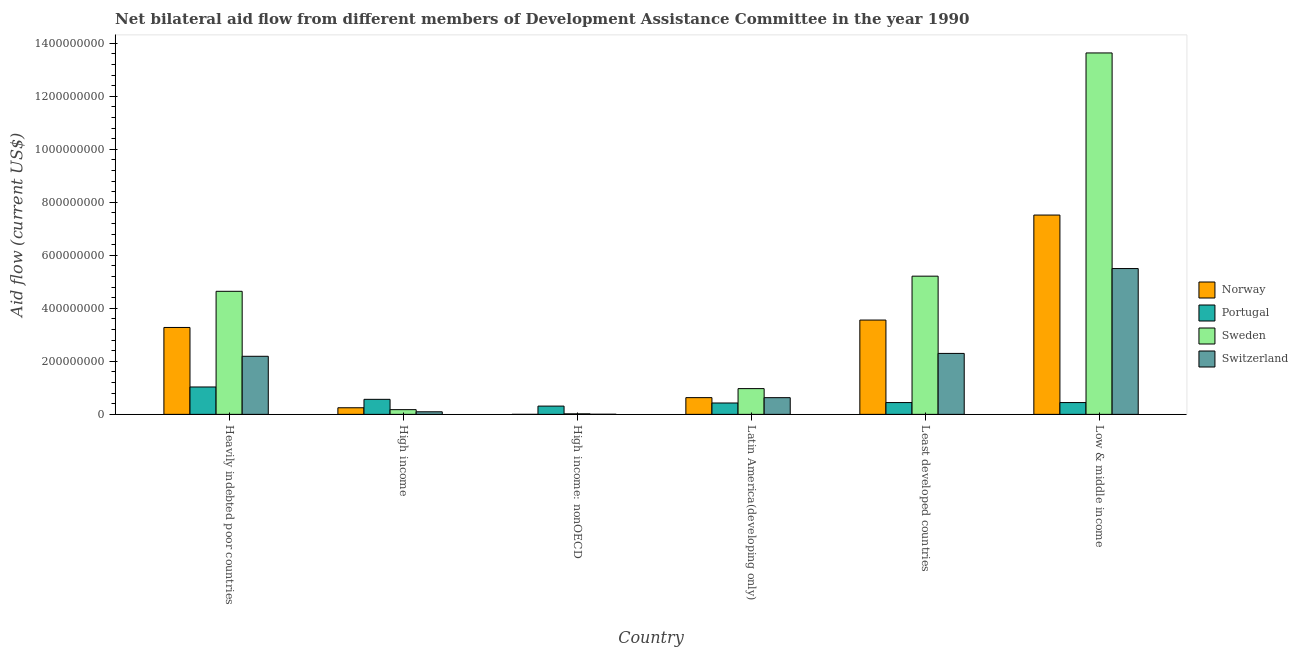How many different coloured bars are there?
Your answer should be very brief. 4. Are the number of bars per tick equal to the number of legend labels?
Your response must be concise. Yes. Are the number of bars on each tick of the X-axis equal?
Give a very brief answer. Yes. How many bars are there on the 1st tick from the left?
Your answer should be very brief. 4. How many bars are there on the 2nd tick from the right?
Provide a succinct answer. 4. What is the label of the 3rd group of bars from the left?
Provide a short and direct response. High income: nonOECD. What is the amount of aid given by norway in Low & middle income?
Offer a terse response. 7.52e+08. Across all countries, what is the maximum amount of aid given by switzerland?
Your answer should be very brief. 5.50e+08. Across all countries, what is the minimum amount of aid given by portugal?
Your response must be concise. 3.12e+07. In which country was the amount of aid given by sweden maximum?
Your response must be concise. Low & middle income. In which country was the amount of aid given by portugal minimum?
Keep it short and to the point. High income: nonOECD. What is the total amount of aid given by norway in the graph?
Make the answer very short. 1.52e+09. What is the difference between the amount of aid given by sweden in Heavily indebted poor countries and that in Low & middle income?
Ensure brevity in your answer.  -8.99e+08. What is the difference between the amount of aid given by switzerland in Latin America(developing only) and the amount of aid given by norway in Low & middle income?
Your answer should be very brief. -6.89e+08. What is the average amount of aid given by norway per country?
Provide a short and direct response. 2.54e+08. What is the difference between the amount of aid given by sweden and amount of aid given by norway in Latin America(developing only)?
Provide a short and direct response. 3.40e+07. What is the ratio of the amount of aid given by sweden in Heavily indebted poor countries to that in Least developed countries?
Your answer should be very brief. 0.89. Is the difference between the amount of aid given by norway in Heavily indebted poor countries and High income greater than the difference between the amount of aid given by switzerland in Heavily indebted poor countries and High income?
Give a very brief answer. Yes. What is the difference between the highest and the second highest amount of aid given by portugal?
Provide a short and direct response. 4.66e+07. What is the difference between the highest and the lowest amount of aid given by sweden?
Offer a terse response. 1.36e+09. In how many countries, is the amount of aid given by portugal greater than the average amount of aid given by portugal taken over all countries?
Offer a very short reply. 2. What does the 4th bar from the left in High income represents?
Offer a terse response. Switzerland. Is it the case that in every country, the sum of the amount of aid given by norway and amount of aid given by portugal is greater than the amount of aid given by sweden?
Your answer should be very brief. No. How many bars are there?
Keep it short and to the point. 24. Are all the bars in the graph horizontal?
Your response must be concise. No. What is the difference between two consecutive major ticks on the Y-axis?
Your answer should be compact. 2.00e+08. Are the values on the major ticks of Y-axis written in scientific E-notation?
Make the answer very short. No. Does the graph contain any zero values?
Your answer should be very brief. No. How are the legend labels stacked?
Your response must be concise. Vertical. What is the title of the graph?
Offer a terse response. Net bilateral aid flow from different members of Development Assistance Committee in the year 1990. Does "Agriculture" appear as one of the legend labels in the graph?
Make the answer very short. No. What is the Aid flow (current US$) of Norway in Heavily indebted poor countries?
Your response must be concise. 3.28e+08. What is the Aid flow (current US$) in Portugal in Heavily indebted poor countries?
Offer a terse response. 1.03e+08. What is the Aid flow (current US$) in Sweden in Heavily indebted poor countries?
Offer a terse response. 4.64e+08. What is the Aid flow (current US$) of Switzerland in Heavily indebted poor countries?
Offer a terse response. 2.19e+08. What is the Aid flow (current US$) in Norway in High income?
Keep it short and to the point. 2.49e+07. What is the Aid flow (current US$) of Portugal in High income?
Give a very brief answer. 5.67e+07. What is the Aid flow (current US$) of Sweden in High income?
Offer a terse response. 1.78e+07. What is the Aid flow (current US$) in Switzerland in High income?
Provide a succinct answer. 9.78e+06. What is the Aid flow (current US$) of Norway in High income: nonOECD?
Your answer should be compact. 5.00e+04. What is the Aid flow (current US$) in Portugal in High income: nonOECD?
Offer a terse response. 3.12e+07. What is the Aid flow (current US$) in Sweden in High income: nonOECD?
Ensure brevity in your answer.  2.03e+06. What is the Aid flow (current US$) in Switzerland in High income: nonOECD?
Your answer should be compact. 5.00e+05. What is the Aid flow (current US$) of Norway in Latin America(developing only)?
Offer a terse response. 6.31e+07. What is the Aid flow (current US$) of Portugal in Latin America(developing only)?
Offer a very short reply. 4.29e+07. What is the Aid flow (current US$) in Sweden in Latin America(developing only)?
Your response must be concise. 9.72e+07. What is the Aid flow (current US$) in Switzerland in Latin America(developing only)?
Offer a terse response. 6.30e+07. What is the Aid flow (current US$) of Norway in Least developed countries?
Offer a terse response. 3.56e+08. What is the Aid flow (current US$) of Portugal in Least developed countries?
Offer a terse response. 4.45e+07. What is the Aid flow (current US$) of Sweden in Least developed countries?
Your answer should be compact. 5.21e+08. What is the Aid flow (current US$) of Switzerland in Least developed countries?
Your answer should be very brief. 2.30e+08. What is the Aid flow (current US$) of Norway in Low & middle income?
Your response must be concise. 7.52e+08. What is the Aid flow (current US$) of Portugal in Low & middle income?
Provide a succinct answer. 4.45e+07. What is the Aid flow (current US$) in Sweden in Low & middle income?
Offer a terse response. 1.36e+09. What is the Aid flow (current US$) of Switzerland in Low & middle income?
Provide a short and direct response. 5.50e+08. Across all countries, what is the maximum Aid flow (current US$) of Norway?
Offer a very short reply. 7.52e+08. Across all countries, what is the maximum Aid flow (current US$) in Portugal?
Keep it short and to the point. 1.03e+08. Across all countries, what is the maximum Aid flow (current US$) in Sweden?
Offer a terse response. 1.36e+09. Across all countries, what is the maximum Aid flow (current US$) of Switzerland?
Provide a short and direct response. 5.50e+08. Across all countries, what is the minimum Aid flow (current US$) in Portugal?
Your answer should be very brief. 3.12e+07. Across all countries, what is the minimum Aid flow (current US$) of Sweden?
Provide a succinct answer. 2.03e+06. Across all countries, what is the minimum Aid flow (current US$) of Switzerland?
Offer a terse response. 5.00e+05. What is the total Aid flow (current US$) in Norway in the graph?
Make the answer very short. 1.52e+09. What is the total Aid flow (current US$) in Portugal in the graph?
Offer a terse response. 3.23e+08. What is the total Aid flow (current US$) in Sweden in the graph?
Provide a succinct answer. 2.47e+09. What is the total Aid flow (current US$) of Switzerland in the graph?
Your answer should be very brief. 1.07e+09. What is the difference between the Aid flow (current US$) in Norway in Heavily indebted poor countries and that in High income?
Your response must be concise. 3.03e+08. What is the difference between the Aid flow (current US$) in Portugal in Heavily indebted poor countries and that in High income?
Your response must be concise. 4.66e+07. What is the difference between the Aid flow (current US$) of Sweden in Heavily indebted poor countries and that in High income?
Make the answer very short. 4.46e+08. What is the difference between the Aid flow (current US$) of Switzerland in Heavily indebted poor countries and that in High income?
Provide a short and direct response. 2.09e+08. What is the difference between the Aid flow (current US$) of Norway in Heavily indebted poor countries and that in High income: nonOECD?
Your answer should be compact. 3.28e+08. What is the difference between the Aid flow (current US$) in Portugal in Heavily indebted poor countries and that in High income: nonOECD?
Your answer should be compact. 7.21e+07. What is the difference between the Aid flow (current US$) of Sweden in Heavily indebted poor countries and that in High income: nonOECD?
Your answer should be very brief. 4.62e+08. What is the difference between the Aid flow (current US$) of Switzerland in Heavily indebted poor countries and that in High income: nonOECD?
Your answer should be very brief. 2.19e+08. What is the difference between the Aid flow (current US$) in Norway in Heavily indebted poor countries and that in Latin America(developing only)?
Your answer should be very brief. 2.65e+08. What is the difference between the Aid flow (current US$) in Portugal in Heavily indebted poor countries and that in Latin America(developing only)?
Provide a short and direct response. 6.04e+07. What is the difference between the Aid flow (current US$) in Sweden in Heavily indebted poor countries and that in Latin America(developing only)?
Your response must be concise. 3.67e+08. What is the difference between the Aid flow (current US$) of Switzerland in Heavily indebted poor countries and that in Latin America(developing only)?
Offer a very short reply. 1.56e+08. What is the difference between the Aid flow (current US$) in Norway in Heavily indebted poor countries and that in Least developed countries?
Offer a very short reply. -2.79e+07. What is the difference between the Aid flow (current US$) of Portugal in Heavily indebted poor countries and that in Least developed countries?
Provide a succinct answer. 5.88e+07. What is the difference between the Aid flow (current US$) of Sweden in Heavily indebted poor countries and that in Least developed countries?
Your answer should be compact. -5.71e+07. What is the difference between the Aid flow (current US$) in Switzerland in Heavily indebted poor countries and that in Least developed countries?
Keep it short and to the point. -1.09e+07. What is the difference between the Aid flow (current US$) in Norway in Heavily indebted poor countries and that in Low & middle income?
Provide a short and direct response. -4.24e+08. What is the difference between the Aid flow (current US$) in Portugal in Heavily indebted poor countries and that in Low & middle income?
Offer a very short reply. 5.88e+07. What is the difference between the Aid flow (current US$) of Sweden in Heavily indebted poor countries and that in Low & middle income?
Your response must be concise. -8.99e+08. What is the difference between the Aid flow (current US$) of Switzerland in Heavily indebted poor countries and that in Low & middle income?
Your answer should be very brief. -3.31e+08. What is the difference between the Aid flow (current US$) of Norway in High income and that in High income: nonOECD?
Offer a terse response. 2.49e+07. What is the difference between the Aid flow (current US$) of Portugal in High income and that in High income: nonOECD?
Offer a very short reply. 2.55e+07. What is the difference between the Aid flow (current US$) in Sweden in High income and that in High income: nonOECD?
Your response must be concise. 1.58e+07. What is the difference between the Aid flow (current US$) of Switzerland in High income and that in High income: nonOECD?
Provide a succinct answer. 9.28e+06. What is the difference between the Aid flow (current US$) of Norway in High income and that in Latin America(developing only)?
Give a very brief answer. -3.82e+07. What is the difference between the Aid flow (current US$) of Portugal in High income and that in Latin America(developing only)?
Offer a very short reply. 1.38e+07. What is the difference between the Aid flow (current US$) of Sweden in High income and that in Latin America(developing only)?
Provide a succinct answer. -7.94e+07. What is the difference between the Aid flow (current US$) in Switzerland in High income and that in Latin America(developing only)?
Your response must be concise. -5.32e+07. What is the difference between the Aid flow (current US$) of Norway in High income and that in Least developed countries?
Your answer should be compact. -3.31e+08. What is the difference between the Aid flow (current US$) of Portugal in High income and that in Least developed countries?
Give a very brief answer. 1.22e+07. What is the difference between the Aid flow (current US$) of Sweden in High income and that in Least developed countries?
Offer a terse response. -5.03e+08. What is the difference between the Aid flow (current US$) in Switzerland in High income and that in Least developed countries?
Offer a terse response. -2.20e+08. What is the difference between the Aid flow (current US$) in Norway in High income and that in Low & middle income?
Provide a succinct answer. -7.27e+08. What is the difference between the Aid flow (current US$) in Portugal in High income and that in Low & middle income?
Offer a very short reply. 1.22e+07. What is the difference between the Aid flow (current US$) of Sweden in High income and that in Low & middle income?
Your answer should be compact. -1.35e+09. What is the difference between the Aid flow (current US$) in Switzerland in High income and that in Low & middle income?
Your answer should be very brief. -5.40e+08. What is the difference between the Aid flow (current US$) of Norway in High income: nonOECD and that in Latin America(developing only)?
Give a very brief answer. -6.31e+07. What is the difference between the Aid flow (current US$) of Portugal in High income: nonOECD and that in Latin America(developing only)?
Make the answer very short. -1.17e+07. What is the difference between the Aid flow (current US$) in Sweden in High income: nonOECD and that in Latin America(developing only)?
Your answer should be very brief. -9.51e+07. What is the difference between the Aid flow (current US$) of Switzerland in High income: nonOECD and that in Latin America(developing only)?
Offer a very short reply. -6.25e+07. What is the difference between the Aid flow (current US$) in Norway in High income: nonOECD and that in Least developed countries?
Make the answer very short. -3.56e+08. What is the difference between the Aid flow (current US$) of Portugal in High income: nonOECD and that in Least developed countries?
Give a very brief answer. -1.33e+07. What is the difference between the Aid flow (current US$) of Sweden in High income: nonOECD and that in Least developed countries?
Ensure brevity in your answer.  -5.19e+08. What is the difference between the Aid flow (current US$) in Switzerland in High income: nonOECD and that in Least developed countries?
Offer a terse response. -2.29e+08. What is the difference between the Aid flow (current US$) of Norway in High income: nonOECD and that in Low & middle income?
Provide a succinct answer. -7.52e+08. What is the difference between the Aid flow (current US$) in Portugal in High income: nonOECD and that in Low & middle income?
Your answer should be compact. -1.33e+07. What is the difference between the Aid flow (current US$) in Sweden in High income: nonOECD and that in Low & middle income?
Make the answer very short. -1.36e+09. What is the difference between the Aid flow (current US$) of Switzerland in High income: nonOECD and that in Low & middle income?
Provide a short and direct response. -5.50e+08. What is the difference between the Aid flow (current US$) in Norway in Latin America(developing only) and that in Least developed countries?
Ensure brevity in your answer.  -2.93e+08. What is the difference between the Aid flow (current US$) in Portugal in Latin America(developing only) and that in Least developed countries?
Your response must be concise. -1.57e+06. What is the difference between the Aid flow (current US$) of Sweden in Latin America(developing only) and that in Least developed countries?
Offer a terse response. -4.24e+08. What is the difference between the Aid flow (current US$) of Switzerland in Latin America(developing only) and that in Least developed countries?
Provide a succinct answer. -1.67e+08. What is the difference between the Aid flow (current US$) in Norway in Latin America(developing only) and that in Low & middle income?
Offer a very short reply. -6.89e+08. What is the difference between the Aid flow (current US$) in Portugal in Latin America(developing only) and that in Low & middle income?
Provide a short and direct response. -1.57e+06. What is the difference between the Aid flow (current US$) of Sweden in Latin America(developing only) and that in Low & middle income?
Your response must be concise. -1.27e+09. What is the difference between the Aid flow (current US$) of Switzerland in Latin America(developing only) and that in Low & middle income?
Give a very brief answer. -4.87e+08. What is the difference between the Aid flow (current US$) in Norway in Least developed countries and that in Low & middle income?
Offer a terse response. -3.96e+08. What is the difference between the Aid flow (current US$) of Sweden in Least developed countries and that in Low & middle income?
Provide a short and direct response. -8.42e+08. What is the difference between the Aid flow (current US$) of Switzerland in Least developed countries and that in Low & middle income?
Your response must be concise. -3.20e+08. What is the difference between the Aid flow (current US$) in Norway in Heavily indebted poor countries and the Aid flow (current US$) in Portugal in High income?
Your answer should be very brief. 2.71e+08. What is the difference between the Aid flow (current US$) in Norway in Heavily indebted poor countries and the Aid flow (current US$) in Sweden in High income?
Keep it short and to the point. 3.10e+08. What is the difference between the Aid flow (current US$) of Norway in Heavily indebted poor countries and the Aid flow (current US$) of Switzerland in High income?
Your response must be concise. 3.18e+08. What is the difference between the Aid flow (current US$) in Portugal in Heavily indebted poor countries and the Aid flow (current US$) in Sweden in High income?
Provide a succinct answer. 8.55e+07. What is the difference between the Aid flow (current US$) of Portugal in Heavily indebted poor countries and the Aid flow (current US$) of Switzerland in High income?
Offer a very short reply. 9.35e+07. What is the difference between the Aid flow (current US$) in Sweden in Heavily indebted poor countries and the Aid flow (current US$) in Switzerland in High income?
Make the answer very short. 4.54e+08. What is the difference between the Aid flow (current US$) of Norway in Heavily indebted poor countries and the Aid flow (current US$) of Portugal in High income: nonOECD?
Give a very brief answer. 2.97e+08. What is the difference between the Aid flow (current US$) of Norway in Heavily indebted poor countries and the Aid flow (current US$) of Sweden in High income: nonOECD?
Your response must be concise. 3.26e+08. What is the difference between the Aid flow (current US$) in Norway in Heavily indebted poor countries and the Aid flow (current US$) in Switzerland in High income: nonOECD?
Your answer should be very brief. 3.27e+08. What is the difference between the Aid flow (current US$) in Portugal in Heavily indebted poor countries and the Aid flow (current US$) in Sweden in High income: nonOECD?
Provide a succinct answer. 1.01e+08. What is the difference between the Aid flow (current US$) of Portugal in Heavily indebted poor countries and the Aid flow (current US$) of Switzerland in High income: nonOECD?
Offer a terse response. 1.03e+08. What is the difference between the Aid flow (current US$) of Sweden in Heavily indebted poor countries and the Aid flow (current US$) of Switzerland in High income: nonOECD?
Your response must be concise. 4.64e+08. What is the difference between the Aid flow (current US$) in Norway in Heavily indebted poor countries and the Aid flow (current US$) in Portugal in Latin America(developing only)?
Ensure brevity in your answer.  2.85e+08. What is the difference between the Aid flow (current US$) of Norway in Heavily indebted poor countries and the Aid flow (current US$) of Sweden in Latin America(developing only)?
Keep it short and to the point. 2.31e+08. What is the difference between the Aid flow (current US$) of Norway in Heavily indebted poor countries and the Aid flow (current US$) of Switzerland in Latin America(developing only)?
Offer a very short reply. 2.65e+08. What is the difference between the Aid flow (current US$) in Portugal in Heavily indebted poor countries and the Aid flow (current US$) in Sweden in Latin America(developing only)?
Provide a short and direct response. 6.15e+06. What is the difference between the Aid flow (current US$) in Portugal in Heavily indebted poor countries and the Aid flow (current US$) in Switzerland in Latin America(developing only)?
Give a very brief answer. 4.03e+07. What is the difference between the Aid flow (current US$) of Sweden in Heavily indebted poor countries and the Aid flow (current US$) of Switzerland in Latin America(developing only)?
Give a very brief answer. 4.01e+08. What is the difference between the Aid flow (current US$) in Norway in Heavily indebted poor countries and the Aid flow (current US$) in Portugal in Least developed countries?
Offer a very short reply. 2.83e+08. What is the difference between the Aid flow (current US$) in Norway in Heavily indebted poor countries and the Aid flow (current US$) in Sweden in Least developed countries?
Make the answer very short. -1.94e+08. What is the difference between the Aid flow (current US$) of Norway in Heavily indebted poor countries and the Aid flow (current US$) of Switzerland in Least developed countries?
Keep it short and to the point. 9.79e+07. What is the difference between the Aid flow (current US$) of Portugal in Heavily indebted poor countries and the Aid flow (current US$) of Sweden in Least developed countries?
Provide a succinct answer. -4.18e+08. What is the difference between the Aid flow (current US$) of Portugal in Heavily indebted poor countries and the Aid flow (current US$) of Switzerland in Least developed countries?
Make the answer very short. -1.27e+08. What is the difference between the Aid flow (current US$) of Sweden in Heavily indebted poor countries and the Aid flow (current US$) of Switzerland in Least developed countries?
Give a very brief answer. 2.34e+08. What is the difference between the Aid flow (current US$) in Norway in Heavily indebted poor countries and the Aid flow (current US$) in Portugal in Low & middle income?
Provide a short and direct response. 2.83e+08. What is the difference between the Aid flow (current US$) in Norway in Heavily indebted poor countries and the Aid flow (current US$) in Sweden in Low & middle income?
Your answer should be compact. -1.04e+09. What is the difference between the Aid flow (current US$) in Norway in Heavily indebted poor countries and the Aid flow (current US$) in Switzerland in Low & middle income?
Your response must be concise. -2.22e+08. What is the difference between the Aid flow (current US$) of Portugal in Heavily indebted poor countries and the Aid flow (current US$) of Sweden in Low & middle income?
Keep it short and to the point. -1.26e+09. What is the difference between the Aid flow (current US$) of Portugal in Heavily indebted poor countries and the Aid flow (current US$) of Switzerland in Low & middle income?
Your answer should be compact. -4.47e+08. What is the difference between the Aid flow (current US$) in Sweden in Heavily indebted poor countries and the Aid flow (current US$) in Switzerland in Low & middle income?
Make the answer very short. -8.58e+07. What is the difference between the Aid flow (current US$) in Norway in High income and the Aid flow (current US$) in Portugal in High income: nonOECD?
Make the answer very short. -6.28e+06. What is the difference between the Aid flow (current US$) in Norway in High income and the Aid flow (current US$) in Sweden in High income: nonOECD?
Your answer should be very brief. 2.29e+07. What is the difference between the Aid flow (current US$) of Norway in High income and the Aid flow (current US$) of Switzerland in High income: nonOECD?
Your answer should be very brief. 2.44e+07. What is the difference between the Aid flow (current US$) of Portugal in High income and the Aid flow (current US$) of Sweden in High income: nonOECD?
Give a very brief answer. 5.47e+07. What is the difference between the Aid flow (current US$) of Portugal in High income and the Aid flow (current US$) of Switzerland in High income: nonOECD?
Give a very brief answer. 5.62e+07. What is the difference between the Aid flow (current US$) in Sweden in High income and the Aid flow (current US$) in Switzerland in High income: nonOECD?
Keep it short and to the point. 1.73e+07. What is the difference between the Aid flow (current US$) of Norway in High income and the Aid flow (current US$) of Portugal in Latin America(developing only)?
Give a very brief answer. -1.80e+07. What is the difference between the Aid flow (current US$) of Norway in High income and the Aid flow (current US$) of Sweden in Latin America(developing only)?
Keep it short and to the point. -7.22e+07. What is the difference between the Aid flow (current US$) in Norway in High income and the Aid flow (current US$) in Switzerland in Latin America(developing only)?
Your answer should be very brief. -3.81e+07. What is the difference between the Aid flow (current US$) of Portugal in High income and the Aid flow (current US$) of Sweden in Latin America(developing only)?
Keep it short and to the point. -4.05e+07. What is the difference between the Aid flow (current US$) of Portugal in High income and the Aid flow (current US$) of Switzerland in Latin America(developing only)?
Give a very brief answer. -6.31e+06. What is the difference between the Aid flow (current US$) of Sweden in High income and the Aid flow (current US$) of Switzerland in Latin America(developing only)?
Your answer should be very brief. -4.52e+07. What is the difference between the Aid flow (current US$) of Norway in High income and the Aid flow (current US$) of Portugal in Least developed countries?
Give a very brief answer. -1.96e+07. What is the difference between the Aid flow (current US$) of Norway in High income and the Aid flow (current US$) of Sweden in Least developed countries?
Offer a terse response. -4.96e+08. What is the difference between the Aid flow (current US$) of Norway in High income and the Aid flow (current US$) of Switzerland in Least developed countries?
Make the answer very short. -2.05e+08. What is the difference between the Aid flow (current US$) of Portugal in High income and the Aid flow (current US$) of Sweden in Least developed countries?
Offer a terse response. -4.65e+08. What is the difference between the Aid flow (current US$) of Portugal in High income and the Aid flow (current US$) of Switzerland in Least developed countries?
Provide a short and direct response. -1.73e+08. What is the difference between the Aid flow (current US$) of Sweden in High income and the Aid flow (current US$) of Switzerland in Least developed countries?
Your response must be concise. -2.12e+08. What is the difference between the Aid flow (current US$) of Norway in High income and the Aid flow (current US$) of Portugal in Low & middle income?
Provide a short and direct response. -1.96e+07. What is the difference between the Aid flow (current US$) in Norway in High income and the Aid flow (current US$) in Sweden in Low & middle income?
Offer a very short reply. -1.34e+09. What is the difference between the Aid flow (current US$) in Norway in High income and the Aid flow (current US$) in Switzerland in Low & middle income?
Provide a short and direct response. -5.25e+08. What is the difference between the Aid flow (current US$) of Portugal in High income and the Aid flow (current US$) of Sweden in Low & middle income?
Provide a short and direct response. -1.31e+09. What is the difference between the Aid flow (current US$) in Portugal in High income and the Aid flow (current US$) in Switzerland in Low & middle income?
Offer a terse response. -4.93e+08. What is the difference between the Aid flow (current US$) of Sweden in High income and the Aid flow (current US$) of Switzerland in Low & middle income?
Ensure brevity in your answer.  -5.32e+08. What is the difference between the Aid flow (current US$) in Norway in High income: nonOECD and the Aid flow (current US$) in Portugal in Latin America(developing only)?
Offer a very short reply. -4.29e+07. What is the difference between the Aid flow (current US$) of Norway in High income: nonOECD and the Aid flow (current US$) of Sweden in Latin America(developing only)?
Keep it short and to the point. -9.71e+07. What is the difference between the Aid flow (current US$) in Norway in High income: nonOECD and the Aid flow (current US$) in Switzerland in Latin America(developing only)?
Provide a short and direct response. -6.30e+07. What is the difference between the Aid flow (current US$) in Portugal in High income: nonOECD and the Aid flow (current US$) in Sweden in Latin America(developing only)?
Ensure brevity in your answer.  -6.59e+07. What is the difference between the Aid flow (current US$) of Portugal in High income: nonOECD and the Aid flow (current US$) of Switzerland in Latin America(developing only)?
Offer a terse response. -3.18e+07. What is the difference between the Aid flow (current US$) of Sweden in High income: nonOECD and the Aid flow (current US$) of Switzerland in Latin America(developing only)?
Provide a succinct answer. -6.10e+07. What is the difference between the Aid flow (current US$) in Norway in High income: nonOECD and the Aid flow (current US$) in Portugal in Least developed countries?
Keep it short and to the point. -4.44e+07. What is the difference between the Aid flow (current US$) in Norway in High income: nonOECD and the Aid flow (current US$) in Sweden in Least developed countries?
Your response must be concise. -5.21e+08. What is the difference between the Aid flow (current US$) of Norway in High income: nonOECD and the Aid flow (current US$) of Switzerland in Least developed countries?
Make the answer very short. -2.30e+08. What is the difference between the Aid flow (current US$) of Portugal in High income: nonOECD and the Aid flow (current US$) of Sweden in Least developed countries?
Give a very brief answer. -4.90e+08. What is the difference between the Aid flow (current US$) in Portugal in High income: nonOECD and the Aid flow (current US$) in Switzerland in Least developed countries?
Offer a terse response. -1.99e+08. What is the difference between the Aid flow (current US$) of Sweden in High income: nonOECD and the Aid flow (current US$) of Switzerland in Least developed countries?
Your answer should be compact. -2.28e+08. What is the difference between the Aid flow (current US$) in Norway in High income: nonOECD and the Aid flow (current US$) in Portugal in Low & middle income?
Give a very brief answer. -4.44e+07. What is the difference between the Aid flow (current US$) in Norway in High income: nonOECD and the Aid flow (current US$) in Sweden in Low & middle income?
Give a very brief answer. -1.36e+09. What is the difference between the Aid flow (current US$) in Norway in High income: nonOECD and the Aid flow (current US$) in Switzerland in Low & middle income?
Give a very brief answer. -5.50e+08. What is the difference between the Aid flow (current US$) of Portugal in High income: nonOECD and the Aid flow (current US$) of Sweden in Low & middle income?
Keep it short and to the point. -1.33e+09. What is the difference between the Aid flow (current US$) in Portugal in High income: nonOECD and the Aid flow (current US$) in Switzerland in Low & middle income?
Your answer should be very brief. -5.19e+08. What is the difference between the Aid flow (current US$) in Sweden in High income: nonOECD and the Aid flow (current US$) in Switzerland in Low & middle income?
Make the answer very short. -5.48e+08. What is the difference between the Aid flow (current US$) of Norway in Latin America(developing only) and the Aid flow (current US$) of Portugal in Least developed countries?
Your answer should be very brief. 1.86e+07. What is the difference between the Aid flow (current US$) of Norway in Latin America(developing only) and the Aid flow (current US$) of Sweden in Least developed countries?
Offer a very short reply. -4.58e+08. What is the difference between the Aid flow (current US$) of Norway in Latin America(developing only) and the Aid flow (current US$) of Switzerland in Least developed countries?
Offer a very short reply. -1.67e+08. What is the difference between the Aid flow (current US$) of Portugal in Latin America(developing only) and the Aid flow (current US$) of Sweden in Least developed countries?
Make the answer very short. -4.78e+08. What is the difference between the Aid flow (current US$) of Portugal in Latin America(developing only) and the Aid flow (current US$) of Switzerland in Least developed countries?
Keep it short and to the point. -1.87e+08. What is the difference between the Aid flow (current US$) in Sweden in Latin America(developing only) and the Aid flow (current US$) in Switzerland in Least developed countries?
Your answer should be very brief. -1.33e+08. What is the difference between the Aid flow (current US$) in Norway in Latin America(developing only) and the Aid flow (current US$) in Portugal in Low & middle income?
Provide a short and direct response. 1.86e+07. What is the difference between the Aid flow (current US$) in Norway in Latin America(developing only) and the Aid flow (current US$) in Sweden in Low & middle income?
Provide a short and direct response. -1.30e+09. What is the difference between the Aid flow (current US$) of Norway in Latin America(developing only) and the Aid flow (current US$) of Switzerland in Low & middle income?
Offer a very short reply. -4.87e+08. What is the difference between the Aid flow (current US$) in Portugal in Latin America(developing only) and the Aid flow (current US$) in Sweden in Low & middle income?
Offer a very short reply. -1.32e+09. What is the difference between the Aid flow (current US$) of Portugal in Latin America(developing only) and the Aid flow (current US$) of Switzerland in Low & middle income?
Offer a terse response. -5.07e+08. What is the difference between the Aid flow (current US$) in Sweden in Latin America(developing only) and the Aid flow (current US$) in Switzerland in Low & middle income?
Your response must be concise. -4.53e+08. What is the difference between the Aid flow (current US$) in Norway in Least developed countries and the Aid flow (current US$) in Portugal in Low & middle income?
Provide a short and direct response. 3.11e+08. What is the difference between the Aid flow (current US$) in Norway in Least developed countries and the Aid flow (current US$) in Sweden in Low & middle income?
Ensure brevity in your answer.  -1.01e+09. What is the difference between the Aid flow (current US$) of Norway in Least developed countries and the Aid flow (current US$) of Switzerland in Low & middle income?
Offer a terse response. -1.94e+08. What is the difference between the Aid flow (current US$) in Portugal in Least developed countries and the Aid flow (current US$) in Sweden in Low & middle income?
Your answer should be very brief. -1.32e+09. What is the difference between the Aid flow (current US$) in Portugal in Least developed countries and the Aid flow (current US$) in Switzerland in Low & middle income?
Offer a terse response. -5.06e+08. What is the difference between the Aid flow (current US$) of Sweden in Least developed countries and the Aid flow (current US$) of Switzerland in Low & middle income?
Ensure brevity in your answer.  -2.87e+07. What is the average Aid flow (current US$) of Norway per country?
Your response must be concise. 2.54e+08. What is the average Aid flow (current US$) of Portugal per country?
Keep it short and to the point. 5.39e+07. What is the average Aid flow (current US$) of Sweden per country?
Your answer should be compact. 4.11e+08. What is the average Aid flow (current US$) of Switzerland per country?
Your answer should be compact. 1.79e+08. What is the difference between the Aid flow (current US$) in Norway and Aid flow (current US$) in Portugal in Heavily indebted poor countries?
Ensure brevity in your answer.  2.24e+08. What is the difference between the Aid flow (current US$) in Norway and Aid flow (current US$) in Sweden in Heavily indebted poor countries?
Keep it short and to the point. -1.36e+08. What is the difference between the Aid flow (current US$) in Norway and Aid flow (current US$) in Switzerland in Heavily indebted poor countries?
Keep it short and to the point. 1.09e+08. What is the difference between the Aid flow (current US$) in Portugal and Aid flow (current US$) in Sweden in Heavily indebted poor countries?
Give a very brief answer. -3.61e+08. What is the difference between the Aid flow (current US$) in Portugal and Aid flow (current US$) in Switzerland in Heavily indebted poor countries?
Provide a succinct answer. -1.16e+08. What is the difference between the Aid flow (current US$) of Sweden and Aid flow (current US$) of Switzerland in Heavily indebted poor countries?
Offer a very short reply. 2.45e+08. What is the difference between the Aid flow (current US$) of Norway and Aid flow (current US$) of Portugal in High income?
Your answer should be compact. -3.18e+07. What is the difference between the Aid flow (current US$) of Norway and Aid flow (current US$) of Sweden in High income?
Keep it short and to the point. 7.13e+06. What is the difference between the Aid flow (current US$) in Norway and Aid flow (current US$) in Switzerland in High income?
Provide a succinct answer. 1.52e+07. What is the difference between the Aid flow (current US$) of Portugal and Aid flow (current US$) of Sweden in High income?
Ensure brevity in your answer.  3.89e+07. What is the difference between the Aid flow (current US$) of Portugal and Aid flow (current US$) of Switzerland in High income?
Keep it short and to the point. 4.69e+07. What is the difference between the Aid flow (current US$) in Sweden and Aid flow (current US$) in Switzerland in High income?
Ensure brevity in your answer.  8.03e+06. What is the difference between the Aid flow (current US$) in Norway and Aid flow (current US$) in Portugal in High income: nonOECD?
Give a very brief answer. -3.12e+07. What is the difference between the Aid flow (current US$) of Norway and Aid flow (current US$) of Sweden in High income: nonOECD?
Your answer should be compact. -1.98e+06. What is the difference between the Aid flow (current US$) of Norway and Aid flow (current US$) of Switzerland in High income: nonOECD?
Offer a very short reply. -4.50e+05. What is the difference between the Aid flow (current US$) of Portugal and Aid flow (current US$) of Sweden in High income: nonOECD?
Your answer should be compact. 2.92e+07. What is the difference between the Aid flow (current US$) of Portugal and Aid flow (current US$) of Switzerland in High income: nonOECD?
Ensure brevity in your answer.  3.07e+07. What is the difference between the Aid flow (current US$) of Sweden and Aid flow (current US$) of Switzerland in High income: nonOECD?
Give a very brief answer. 1.53e+06. What is the difference between the Aid flow (current US$) of Norway and Aid flow (current US$) of Portugal in Latin America(developing only)?
Offer a very short reply. 2.02e+07. What is the difference between the Aid flow (current US$) of Norway and Aid flow (current US$) of Sweden in Latin America(developing only)?
Provide a short and direct response. -3.40e+07. What is the difference between the Aid flow (current US$) of Norway and Aid flow (current US$) of Switzerland in Latin America(developing only)?
Your response must be concise. 1.20e+05. What is the difference between the Aid flow (current US$) in Portugal and Aid flow (current US$) in Sweden in Latin America(developing only)?
Offer a very short reply. -5.42e+07. What is the difference between the Aid flow (current US$) of Portugal and Aid flow (current US$) of Switzerland in Latin America(developing only)?
Offer a very short reply. -2.01e+07. What is the difference between the Aid flow (current US$) in Sweden and Aid flow (current US$) in Switzerland in Latin America(developing only)?
Give a very brief answer. 3.42e+07. What is the difference between the Aid flow (current US$) of Norway and Aid flow (current US$) of Portugal in Least developed countries?
Provide a short and direct response. 3.11e+08. What is the difference between the Aid flow (current US$) in Norway and Aid flow (current US$) in Sweden in Least developed countries?
Provide a short and direct response. -1.66e+08. What is the difference between the Aid flow (current US$) of Norway and Aid flow (current US$) of Switzerland in Least developed countries?
Offer a terse response. 1.26e+08. What is the difference between the Aid flow (current US$) in Portugal and Aid flow (current US$) in Sweden in Least developed countries?
Your response must be concise. -4.77e+08. What is the difference between the Aid flow (current US$) of Portugal and Aid flow (current US$) of Switzerland in Least developed countries?
Keep it short and to the point. -1.85e+08. What is the difference between the Aid flow (current US$) of Sweden and Aid flow (current US$) of Switzerland in Least developed countries?
Make the answer very short. 2.91e+08. What is the difference between the Aid flow (current US$) in Norway and Aid flow (current US$) in Portugal in Low & middle income?
Offer a very short reply. 7.07e+08. What is the difference between the Aid flow (current US$) of Norway and Aid flow (current US$) of Sweden in Low & middle income?
Your answer should be compact. -6.11e+08. What is the difference between the Aid flow (current US$) of Norway and Aid flow (current US$) of Switzerland in Low & middle income?
Your response must be concise. 2.02e+08. What is the difference between the Aid flow (current US$) of Portugal and Aid flow (current US$) of Sweden in Low & middle income?
Offer a terse response. -1.32e+09. What is the difference between the Aid flow (current US$) of Portugal and Aid flow (current US$) of Switzerland in Low & middle income?
Ensure brevity in your answer.  -5.06e+08. What is the difference between the Aid flow (current US$) of Sweden and Aid flow (current US$) of Switzerland in Low & middle income?
Provide a short and direct response. 8.13e+08. What is the ratio of the Aid flow (current US$) in Norway in Heavily indebted poor countries to that in High income?
Your answer should be compact. 13.14. What is the ratio of the Aid flow (current US$) of Portugal in Heavily indebted poor countries to that in High income?
Your answer should be compact. 1.82. What is the ratio of the Aid flow (current US$) in Sweden in Heavily indebted poor countries to that in High income?
Ensure brevity in your answer.  26.06. What is the ratio of the Aid flow (current US$) in Switzerland in Heavily indebted poor countries to that in High income?
Offer a very short reply. 22.4. What is the ratio of the Aid flow (current US$) of Norway in Heavily indebted poor countries to that in High income: nonOECD?
Give a very brief answer. 6555.8. What is the ratio of the Aid flow (current US$) of Portugal in Heavily indebted poor countries to that in High income: nonOECD?
Your answer should be very brief. 3.31. What is the ratio of the Aid flow (current US$) of Sweden in Heavily indebted poor countries to that in High income: nonOECD?
Offer a terse response. 228.67. What is the ratio of the Aid flow (current US$) in Switzerland in Heavily indebted poor countries to that in High income: nonOECD?
Give a very brief answer. 438.14. What is the ratio of the Aid flow (current US$) of Norway in Heavily indebted poor countries to that in Latin America(developing only)?
Keep it short and to the point. 5.19. What is the ratio of the Aid flow (current US$) in Portugal in Heavily indebted poor countries to that in Latin America(developing only)?
Offer a terse response. 2.41. What is the ratio of the Aid flow (current US$) in Sweden in Heavily indebted poor countries to that in Latin America(developing only)?
Ensure brevity in your answer.  4.78. What is the ratio of the Aid flow (current US$) of Switzerland in Heavily indebted poor countries to that in Latin America(developing only)?
Your answer should be very brief. 3.48. What is the ratio of the Aid flow (current US$) of Norway in Heavily indebted poor countries to that in Least developed countries?
Make the answer very short. 0.92. What is the ratio of the Aid flow (current US$) of Portugal in Heavily indebted poor countries to that in Least developed countries?
Keep it short and to the point. 2.32. What is the ratio of the Aid flow (current US$) in Sweden in Heavily indebted poor countries to that in Least developed countries?
Ensure brevity in your answer.  0.89. What is the ratio of the Aid flow (current US$) in Switzerland in Heavily indebted poor countries to that in Least developed countries?
Provide a short and direct response. 0.95. What is the ratio of the Aid flow (current US$) in Norway in Heavily indebted poor countries to that in Low & middle income?
Provide a succinct answer. 0.44. What is the ratio of the Aid flow (current US$) in Portugal in Heavily indebted poor countries to that in Low & middle income?
Give a very brief answer. 2.32. What is the ratio of the Aid flow (current US$) of Sweden in Heavily indebted poor countries to that in Low & middle income?
Your answer should be very brief. 0.34. What is the ratio of the Aid flow (current US$) of Switzerland in Heavily indebted poor countries to that in Low & middle income?
Your answer should be compact. 0.4. What is the ratio of the Aid flow (current US$) of Norway in High income to that in High income: nonOECD?
Your answer should be very brief. 498.8. What is the ratio of the Aid flow (current US$) of Portugal in High income to that in High income: nonOECD?
Your answer should be compact. 1.82. What is the ratio of the Aid flow (current US$) in Sweden in High income to that in High income: nonOECD?
Make the answer very short. 8.77. What is the ratio of the Aid flow (current US$) in Switzerland in High income to that in High income: nonOECD?
Your answer should be very brief. 19.56. What is the ratio of the Aid flow (current US$) in Norway in High income to that in Latin America(developing only)?
Ensure brevity in your answer.  0.4. What is the ratio of the Aid flow (current US$) of Portugal in High income to that in Latin America(developing only)?
Give a very brief answer. 1.32. What is the ratio of the Aid flow (current US$) in Sweden in High income to that in Latin America(developing only)?
Provide a succinct answer. 0.18. What is the ratio of the Aid flow (current US$) in Switzerland in High income to that in Latin America(developing only)?
Make the answer very short. 0.16. What is the ratio of the Aid flow (current US$) of Norway in High income to that in Least developed countries?
Offer a terse response. 0.07. What is the ratio of the Aid flow (current US$) in Portugal in High income to that in Least developed countries?
Offer a terse response. 1.27. What is the ratio of the Aid flow (current US$) of Sweden in High income to that in Least developed countries?
Your answer should be compact. 0.03. What is the ratio of the Aid flow (current US$) of Switzerland in High income to that in Least developed countries?
Ensure brevity in your answer.  0.04. What is the ratio of the Aid flow (current US$) of Norway in High income to that in Low & middle income?
Your answer should be compact. 0.03. What is the ratio of the Aid flow (current US$) of Portugal in High income to that in Low & middle income?
Your response must be concise. 1.27. What is the ratio of the Aid flow (current US$) of Sweden in High income to that in Low & middle income?
Your response must be concise. 0.01. What is the ratio of the Aid flow (current US$) in Switzerland in High income to that in Low & middle income?
Make the answer very short. 0.02. What is the ratio of the Aid flow (current US$) of Norway in High income: nonOECD to that in Latin America(developing only)?
Provide a succinct answer. 0. What is the ratio of the Aid flow (current US$) in Portugal in High income: nonOECD to that in Latin America(developing only)?
Keep it short and to the point. 0.73. What is the ratio of the Aid flow (current US$) of Sweden in High income: nonOECD to that in Latin America(developing only)?
Your response must be concise. 0.02. What is the ratio of the Aid flow (current US$) in Switzerland in High income: nonOECD to that in Latin America(developing only)?
Keep it short and to the point. 0.01. What is the ratio of the Aid flow (current US$) in Norway in High income: nonOECD to that in Least developed countries?
Provide a short and direct response. 0. What is the ratio of the Aid flow (current US$) of Portugal in High income: nonOECD to that in Least developed countries?
Keep it short and to the point. 0.7. What is the ratio of the Aid flow (current US$) of Sweden in High income: nonOECD to that in Least developed countries?
Your response must be concise. 0. What is the ratio of the Aid flow (current US$) in Switzerland in High income: nonOECD to that in Least developed countries?
Ensure brevity in your answer.  0. What is the ratio of the Aid flow (current US$) in Portugal in High income: nonOECD to that in Low & middle income?
Your response must be concise. 0.7. What is the ratio of the Aid flow (current US$) of Sweden in High income: nonOECD to that in Low & middle income?
Your response must be concise. 0. What is the ratio of the Aid flow (current US$) in Switzerland in High income: nonOECD to that in Low & middle income?
Offer a terse response. 0. What is the ratio of the Aid flow (current US$) in Norway in Latin America(developing only) to that in Least developed countries?
Keep it short and to the point. 0.18. What is the ratio of the Aid flow (current US$) of Portugal in Latin America(developing only) to that in Least developed countries?
Provide a succinct answer. 0.96. What is the ratio of the Aid flow (current US$) of Sweden in Latin America(developing only) to that in Least developed countries?
Ensure brevity in your answer.  0.19. What is the ratio of the Aid flow (current US$) of Switzerland in Latin America(developing only) to that in Least developed countries?
Offer a very short reply. 0.27. What is the ratio of the Aid flow (current US$) of Norway in Latin America(developing only) to that in Low & middle income?
Ensure brevity in your answer.  0.08. What is the ratio of the Aid flow (current US$) in Portugal in Latin America(developing only) to that in Low & middle income?
Offer a terse response. 0.96. What is the ratio of the Aid flow (current US$) in Sweden in Latin America(developing only) to that in Low & middle income?
Offer a very short reply. 0.07. What is the ratio of the Aid flow (current US$) in Switzerland in Latin America(developing only) to that in Low & middle income?
Your answer should be very brief. 0.11. What is the ratio of the Aid flow (current US$) of Norway in Least developed countries to that in Low & middle income?
Provide a short and direct response. 0.47. What is the ratio of the Aid flow (current US$) of Sweden in Least developed countries to that in Low & middle income?
Offer a terse response. 0.38. What is the ratio of the Aid flow (current US$) of Switzerland in Least developed countries to that in Low & middle income?
Your answer should be compact. 0.42. What is the difference between the highest and the second highest Aid flow (current US$) of Norway?
Your answer should be very brief. 3.96e+08. What is the difference between the highest and the second highest Aid flow (current US$) of Portugal?
Your answer should be compact. 4.66e+07. What is the difference between the highest and the second highest Aid flow (current US$) in Sweden?
Your answer should be compact. 8.42e+08. What is the difference between the highest and the second highest Aid flow (current US$) of Switzerland?
Keep it short and to the point. 3.20e+08. What is the difference between the highest and the lowest Aid flow (current US$) in Norway?
Your answer should be compact. 7.52e+08. What is the difference between the highest and the lowest Aid flow (current US$) in Portugal?
Give a very brief answer. 7.21e+07. What is the difference between the highest and the lowest Aid flow (current US$) of Sweden?
Your response must be concise. 1.36e+09. What is the difference between the highest and the lowest Aid flow (current US$) in Switzerland?
Your response must be concise. 5.50e+08. 